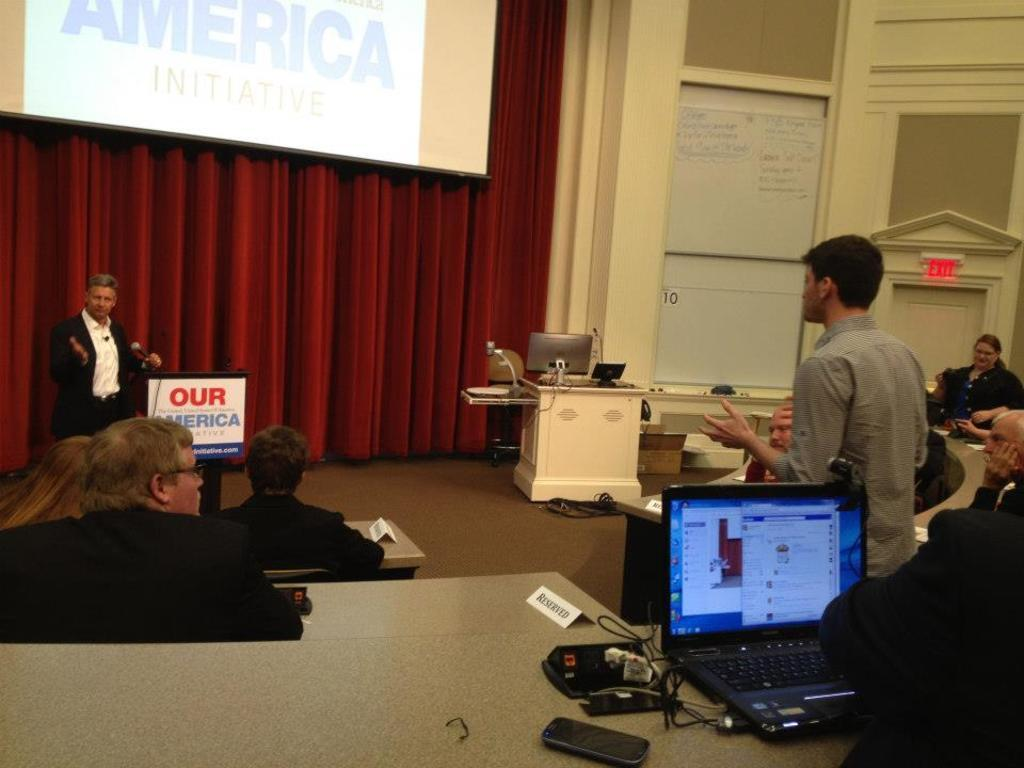Provide a one-sentence caption for the provided image. A man giving a speech behind a podium that says, "Our America.". 